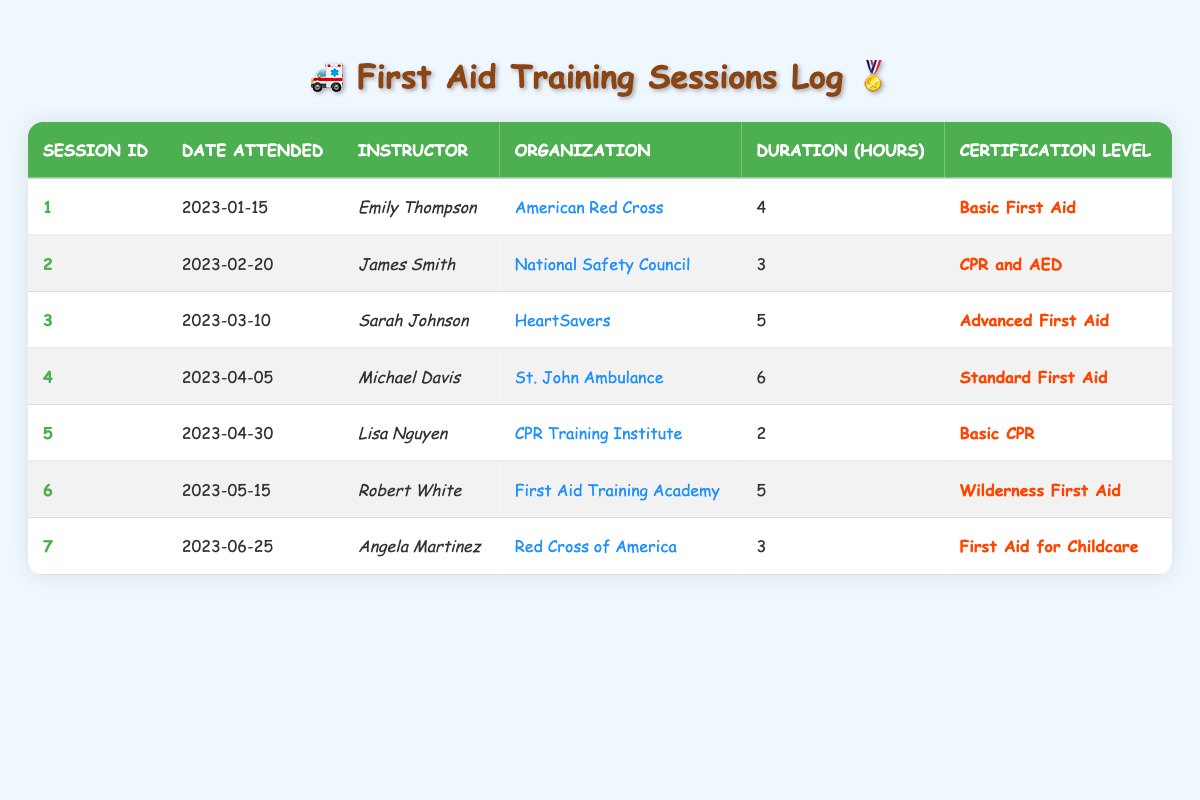What is the date of the training session conducted by Emily Thompson? The table lists the session conducted by Emily Thompson in the row where the instructor name is "Emily Thompson". The corresponding date in that row is "2023-01-15".
Answer: 2023-01-15 How many hours did the session for Wilderness First Aid last? The session for Wilderness First Aid is found in the row marked with certification level "Wilderness First Aid". The duration in that row is 5 hours.
Answer: 5 Which organization provided the CPR and AED training session? The organization for the session titled "CPR and AED" can be found in the row where the certification level is "CPR and AED". The organization listed in that row is "National Safety Council".
Answer: National Safety Council What is the certification level of the session that took place on April 5, 2023? The date "2023-04-05" can be located in the table. The row corresponding to that date shows the session's certification level as "Standard First Aid".
Answer: Standard First Aid Which instructor taught the longest training session and what was its duration? To find the longest training session, look at the duration column. The longest duration is 6 hours, which corresponds to the session taught by Michael Davis, as noted in the organization "St. John Ambulance."
Answer: Michael Davis, 6 How many training sessions had a duration of more than 4 hours? We will look through the duration values and count those greater than 4 hours. Sessions 3, 4, and 6 fit this criterion: Advanced First Aid (5 hours), Standard First Aid (6 hours), and Wilderness First Aid (5 hours). Therefore, there are 3 training sessions over 4 hours.
Answer: 3 Is there a training session focused on childcare in the table? Review the certification levels listed in the table. We find "First Aid for Childcare" among the certification levels, indicating there is a specialized session for childcare.
Answer: Yes What was the average duration of all training sessions attended? The total duration of all sessions is calculated by summing the durations: (4 + 3 + 5 + 6 + 2 + 5 + 3) = 28 hours. There are 7 sessions, so the average duration is 28/7 = 4 hours.
Answer: 4 Which session had the earliest date and what certification level was it? The earliest date can be found by looking at the date attended for each session. The earliest date is "2023-01-15" for the session with the certification level "Basic First Aid".
Answer: Basic First Aid What is the total number of hours from all training sessions combined? To find the total hours, sum up all the durations listed: 4 + 3 + 5 + 6 + 2 + 5 + 3 = 28 hours.
Answer: 28 